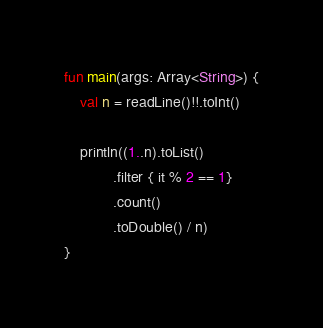<code> <loc_0><loc_0><loc_500><loc_500><_Kotlin_>fun main(args: Array<String>) {
    val n = readLine()!!.toInt()

    println((1..n).toList()
            .filter { it % 2 == 1}
            .count()
            .toDouble() / n)
}</code> 